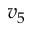<formula> <loc_0><loc_0><loc_500><loc_500>v _ { 5 }</formula> 